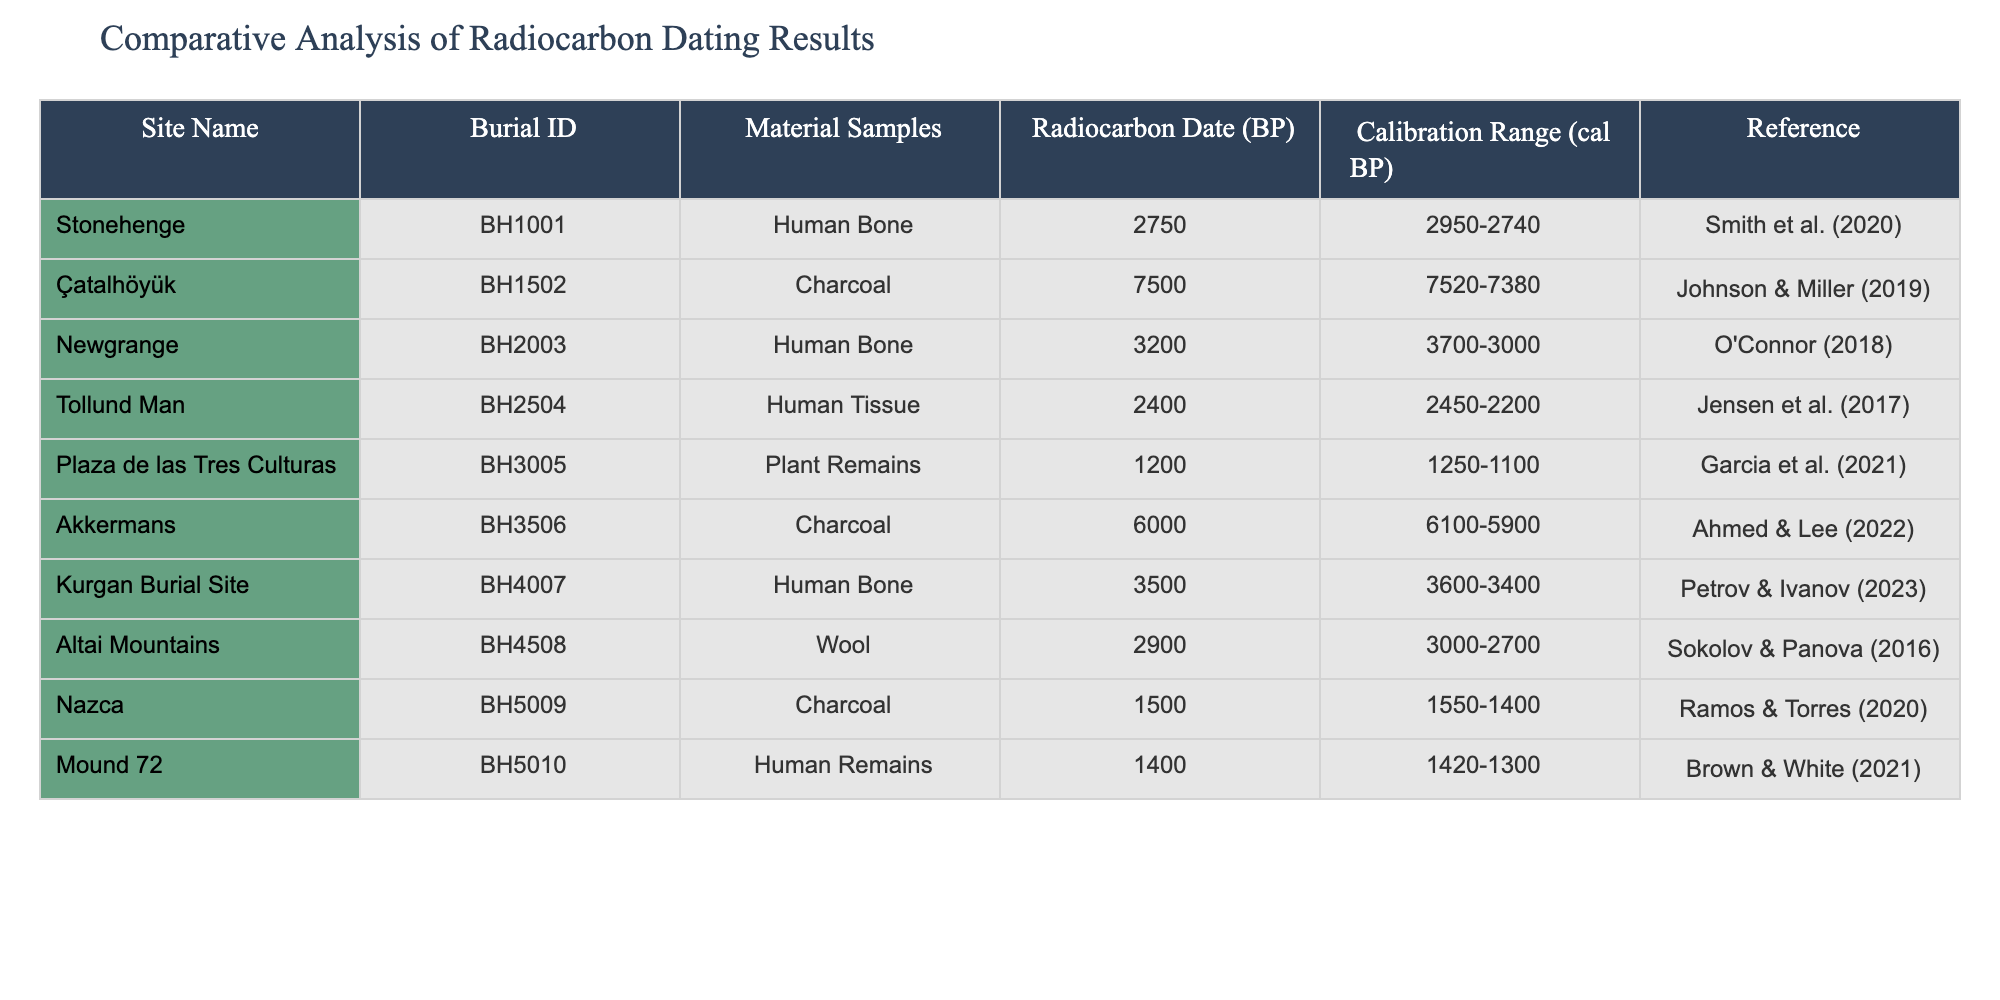What is the radiocarbon date (BP) for the burial at Stonehenge? The table indicates that the radiocarbon date (BP) for the burial at Stonehenge is 2750.
Answer: 2750 Which burial site has the earliest calibration range? Looking through the calibration ranges in the table, the burial at Çatalhöyük has the earliest range of 7520 to 7380 cal BP.
Answer: Çatalhöyük Is the burial at Newgrange older than the burial at Kurgan Burial Site? The radiocarbon date for Newgrange is 3200 BP while for Kurgan Burial Site it is 3500 BP. Since 3200 is younger than 3500, the burial at Newgrange is not older.
Answer: No What is the average radiocarbon date (BP) for the burials that used human bone? The radiocarbon dates for burials that used human bone are 2750 (Stonehenge), 3200 (Newgrange), 2400 (Tollund Man), and 3500 (Kurgan Burial Site). Summing them gives 2750 + 3200 + 2400 + 3500 = 11850, and dividing by 4 gives an average of 2962.5, which rounds to 2963.
Answer: 2963 How many burial sites in the table have a calibration range that goes beyond 3000 cal BP? The calibration ranges for Çatalhöyük (7520-7380), Akkermans (6100-5900), and Newgrange (3700-3000) extend beyond 3000 cal BP. Thus, there are three such burials.
Answer: 3 Which material sample was dated to approximately 1500 cal BP? Referring to the table, the material sample Charcoal from the Nazca site, with a radiocarbon date of 1500 BP, fits this criterion as it has a calibration range of 1550-1400.
Answer: Charcoal Are any burials dated from before 1500 BP? By inspecting the radiocarbon dates in the table, we see that the burial dates for Çatalhöyük (7500 BP), Akkermans (6000 BP), and Mound 72 (1400 BP) show that there are multiple burials dated before 1500 BP.
Answer: Yes What is the difference in the earliest and latest calibration ranges in the table? The earliest calibration range starts at 7380 cal BP (Çatalhöyük) and the latest calibration range ends at 2740 cal BP (Stonehenge). The difference is calculated as the earliest start (7380) minus the latest end (2740), giving 7380 - 2740 = 4640.
Answer: 4640 